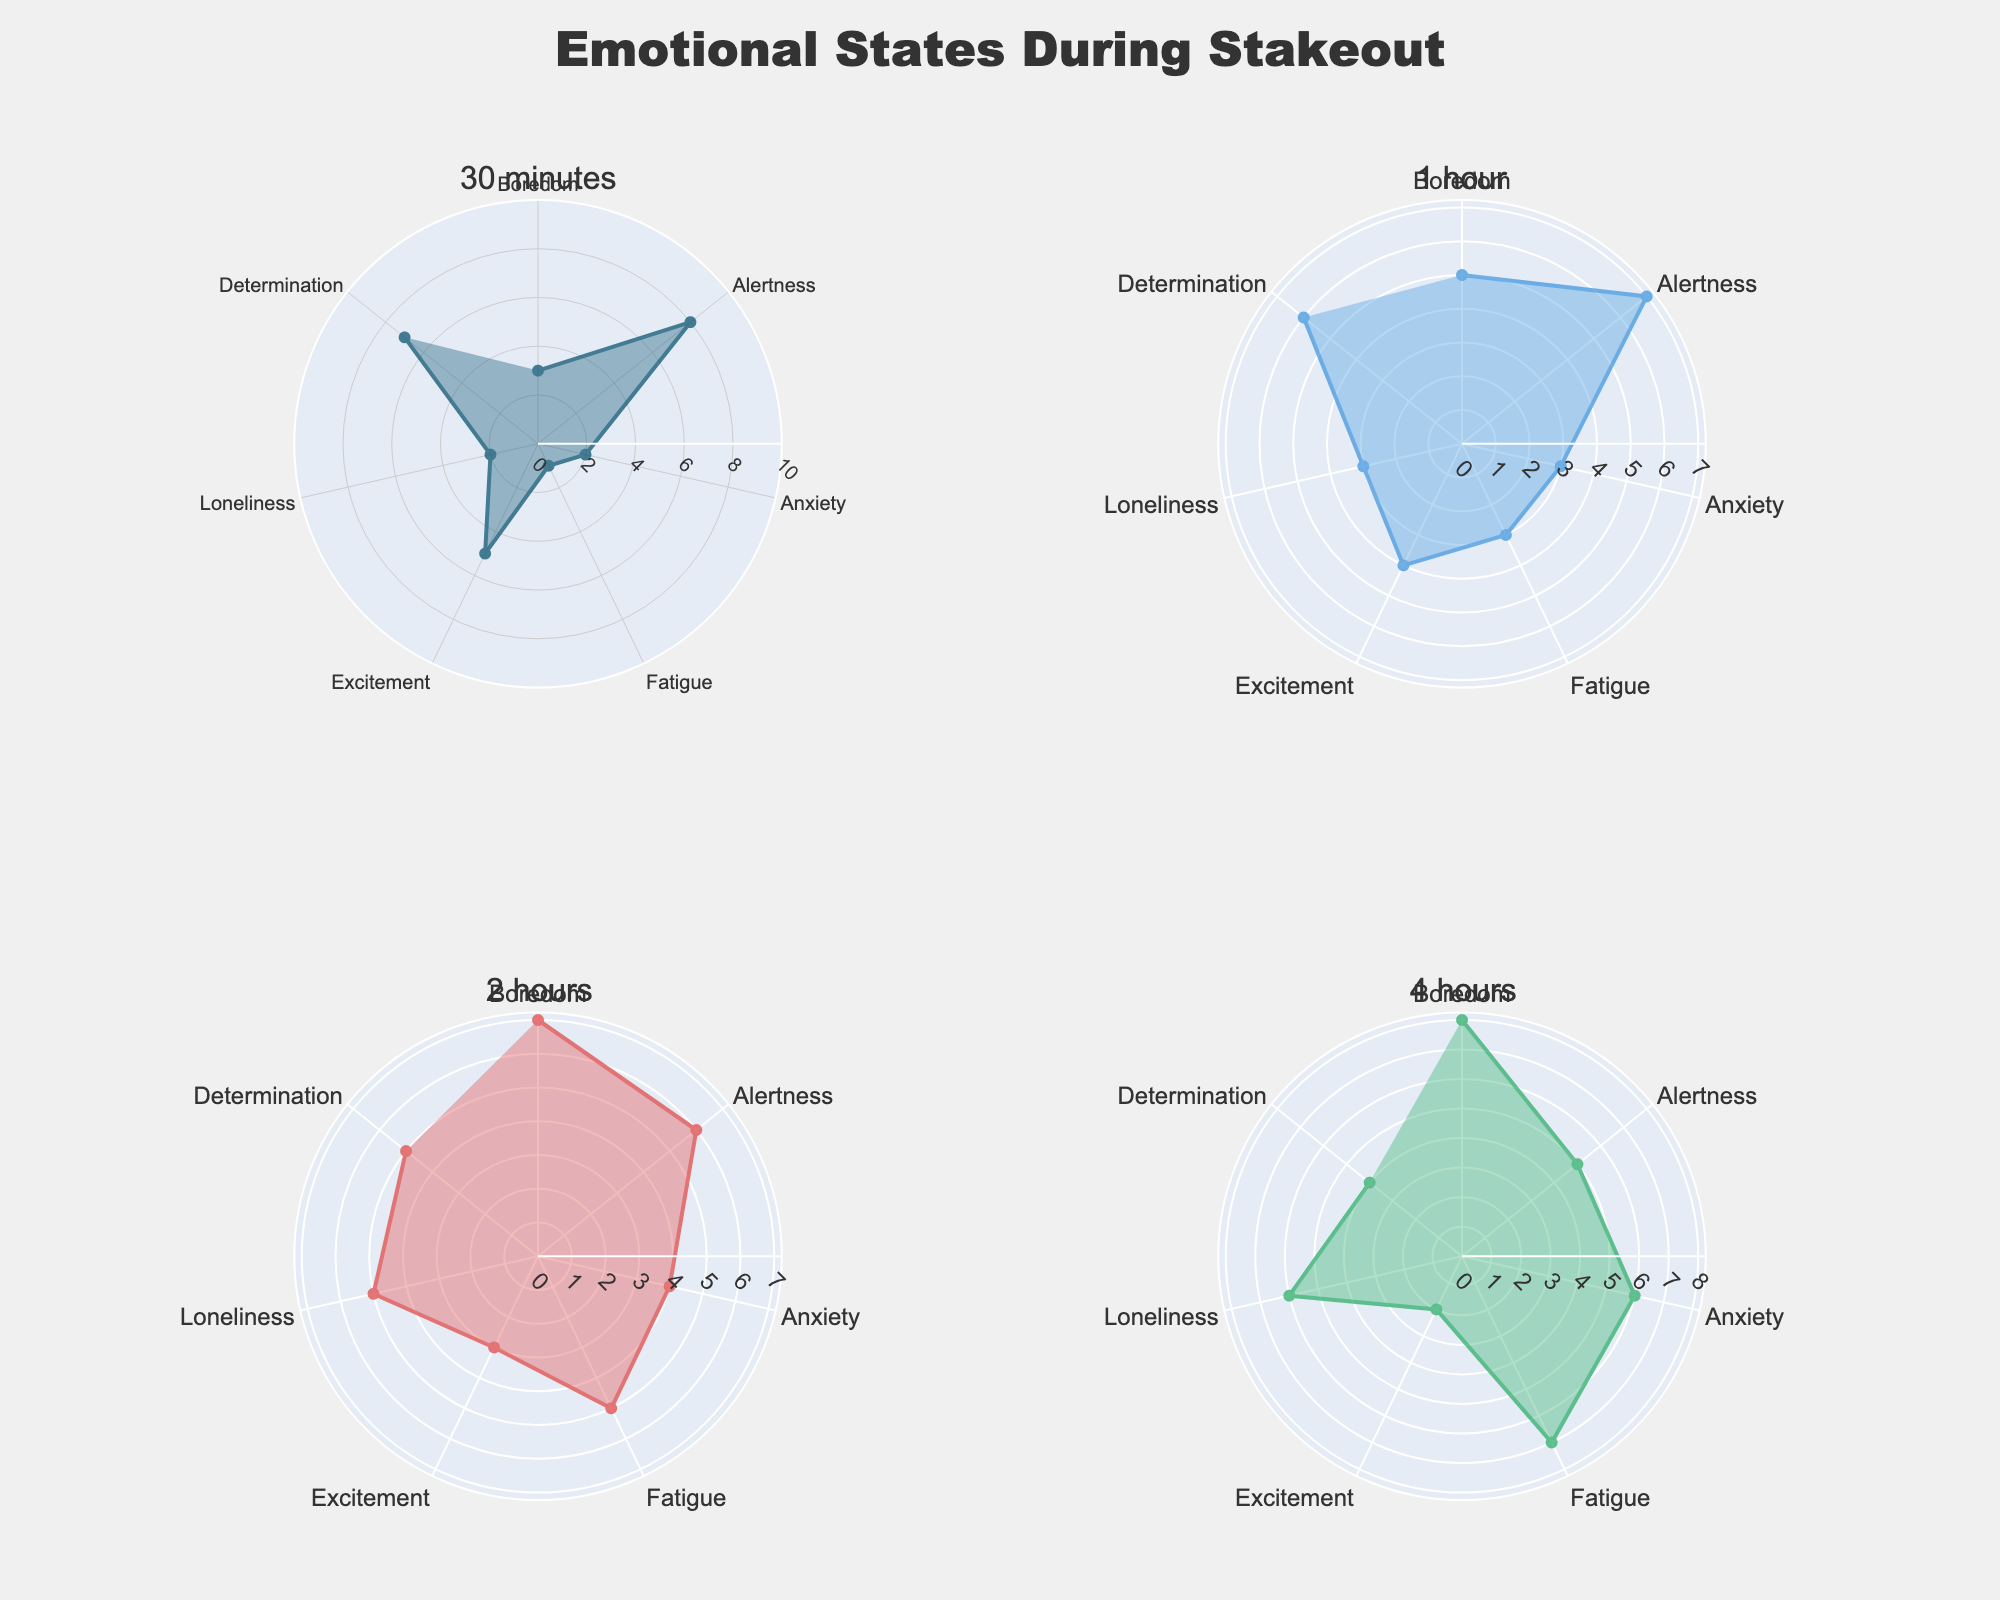What is the title of the figure? The title is usually displayed at the top of the chart and helps to quickly communicate the subject of the figure.
Answer: Emotional States During Stakeout How many radar charts are displayed in the figure? By examining the layout of the figure, we can observe that it contains multiple subplots arranged in a 2x2 grid. Each subplot corresponds to a different duration.
Answer: 4 Which emotional state decreases the most from 30 minutes to 4 hours? To answer this, observe the lines representing each emotional state across the 30 minutes and 4 hours plots. Note the changes in values.
Answer: Excitement Among the emotional states listed, which one shows the highest initial value at the 30 minutes mark? By looking at the radar chart for 30 minutes, identify and compare the values for each emotional state. The highest initial value can be determined.
Answer: Alertness Which emotional state shows the greatest increase from 30 minutes to 4 hours? Compare the values of each emotional state at the 30 minutes and 4 hours marks. Calculate the difference for each and identify the one with the largest increase.
Answer: Anxiety What is the sum of the values for Determination across all durations? Add up the values for Determination at 30 minutes, 1 hour, 2 hours, and 4 hours.
Answer: 22 Which emotional state has the least variation in values across different durations? To find the least variation, observe the range of values for each emotional state over the different durations and identify the one with the smallest difference between its highest and lowest values.
Answer: Determination In which duration is Loneliness equal to Fatigue? By checking each radar chart for the point where the values for Loneliness and Fatigue match, we find the duration.
Answer: 4 hours What is the average value of Boredom across all durations? Sum the values for Boredom at 30 minutes, 1 hour, 2 hours, and 4 hours, and then divide by the number of durations.
Answer: 5.75 How does the value of Alertness change from 30 minutes to 4 hours? Track the values of Alertness at 30 minutes, 1 hour, 2 hours, and 4 hours, and note the trend.
Answer: Decreases 